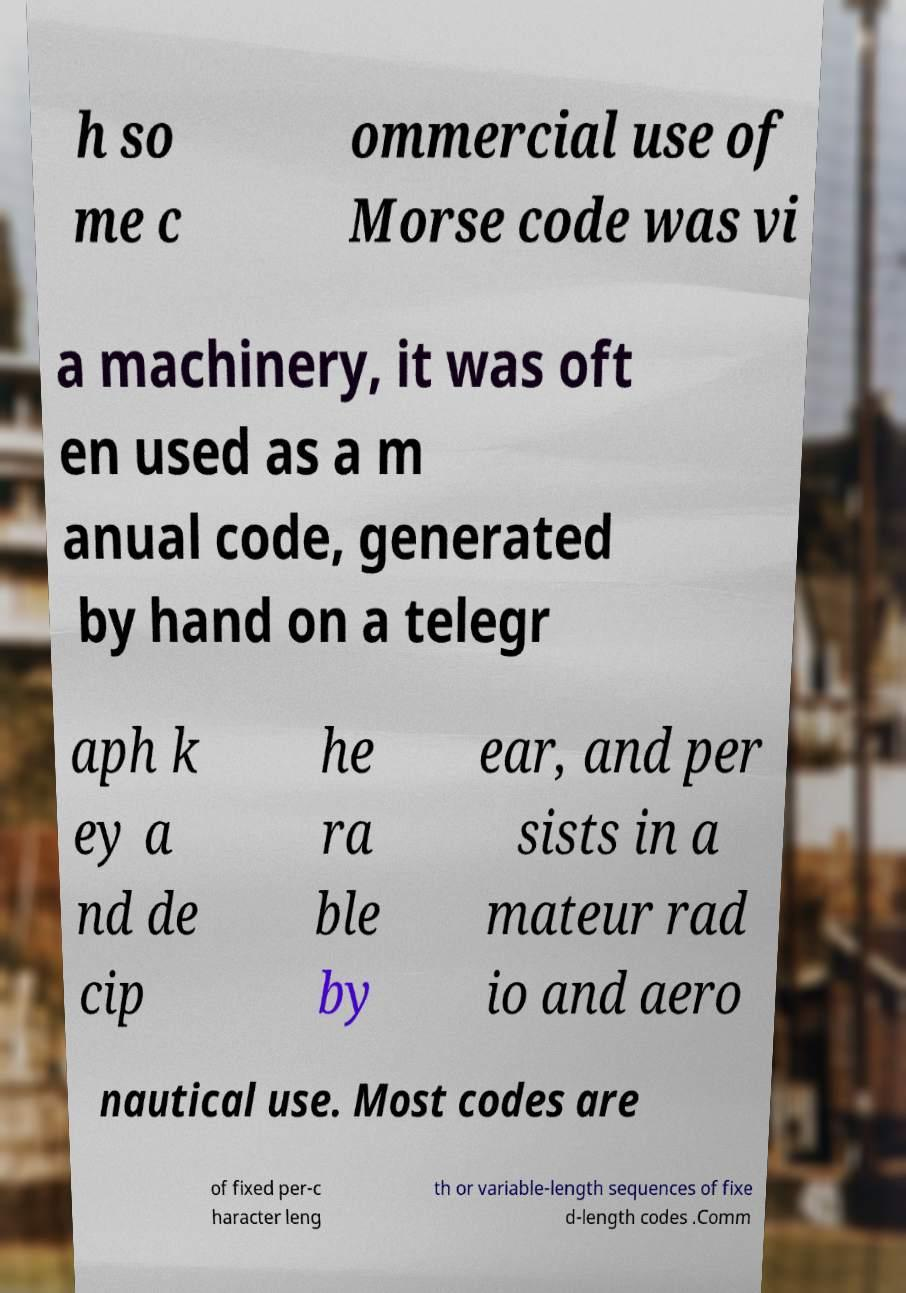What messages or text are displayed in this image? I need them in a readable, typed format. h so me c ommercial use of Morse code was vi a machinery, it was oft en used as a m anual code, generated by hand on a telegr aph k ey a nd de cip he ra ble by ear, and per sists in a mateur rad io and aero nautical use. Most codes are of fixed per-c haracter leng th or variable-length sequences of fixe d-length codes .Comm 